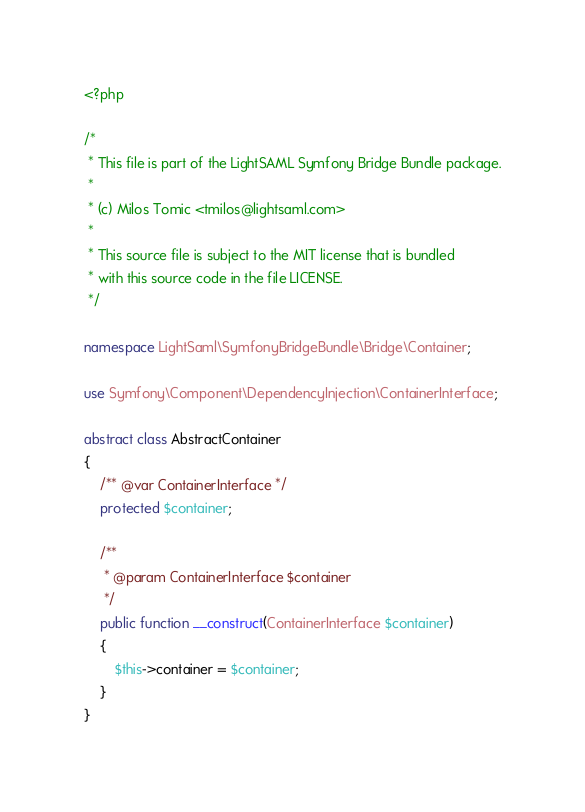<code> <loc_0><loc_0><loc_500><loc_500><_PHP_><?php

/*
 * This file is part of the LightSAML Symfony Bridge Bundle package.
 *
 * (c) Milos Tomic <tmilos@lightsaml.com>
 *
 * This source file is subject to the MIT license that is bundled
 * with this source code in the file LICENSE.
 */

namespace LightSaml\SymfonyBridgeBundle\Bridge\Container;

use Symfony\Component\DependencyInjection\ContainerInterface;

abstract class AbstractContainer
{
    /** @var ContainerInterface */
    protected $container;

    /**
     * @param ContainerInterface $container
     */
    public function __construct(ContainerInterface $container)
    {
        $this->container = $container;
    }
}
</code> 